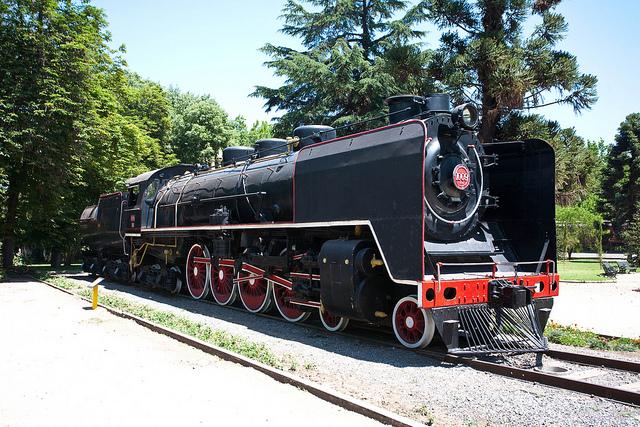Is there a yellow thing near the train?
Be succinct. Yes. What is the metal grate on the front of the train?
Short answer required. Cowcatcher. What type of vehicle is this?
Answer briefly. Train. 